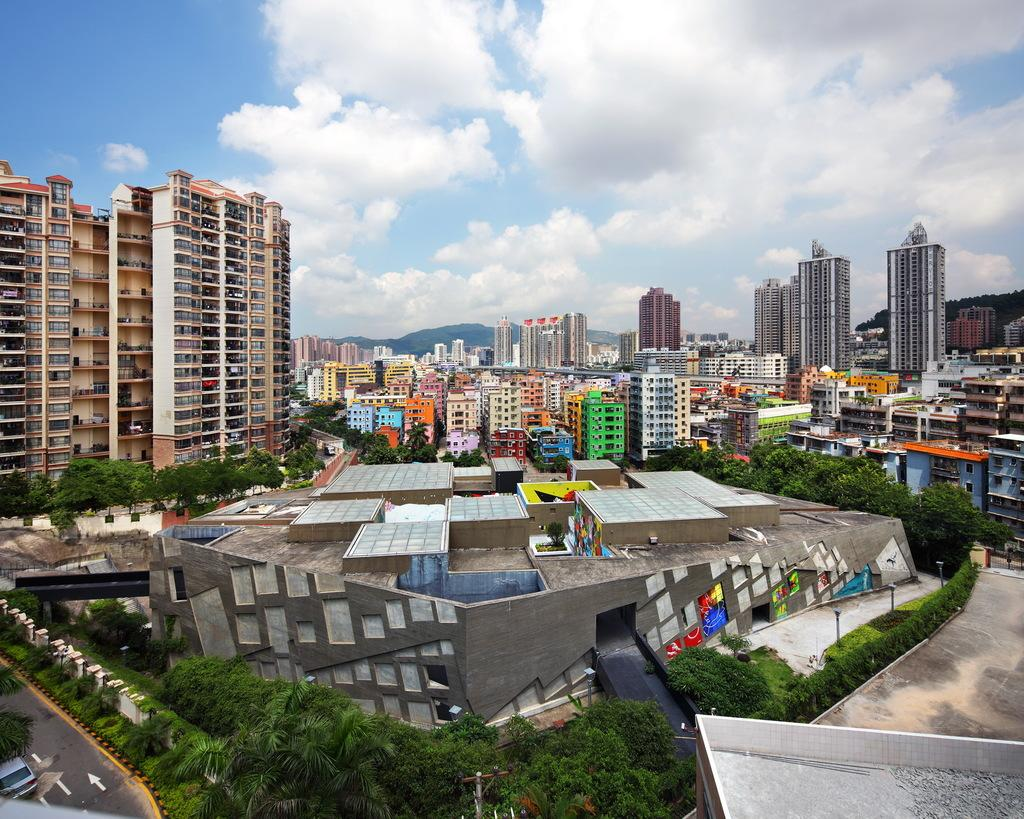What can be seen on the left side of the image? There is a car on the road on the left side of the image. What type of natural elements are present in the image? There are trees and plants in the image. What type of man-made structures can be seen in the image? There are buildings in the image. What is visible in the sky at the top of the image? There are clouds in the sky at the top of the image. What type of wine is being served at the work meeting in the image? There is no work meeting or wine present in the image. 